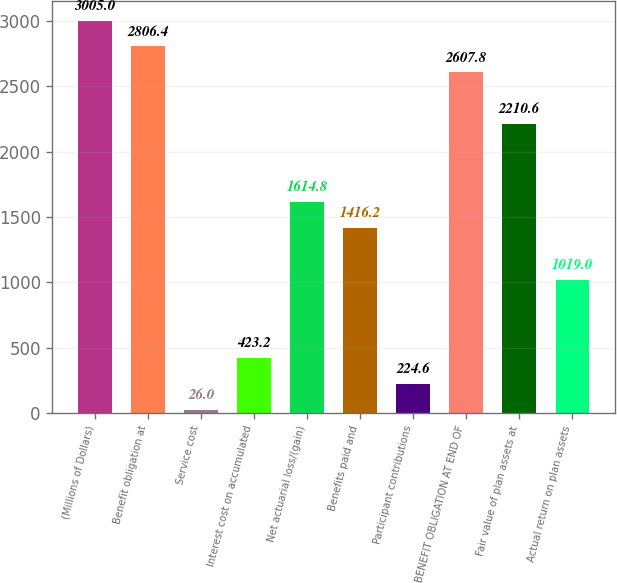Convert chart to OTSL. <chart><loc_0><loc_0><loc_500><loc_500><bar_chart><fcel>(Millions of Dollars)<fcel>Benefit obligation at<fcel>Service cost<fcel>Interest cost on accumulated<fcel>Net actuarial loss/(gain)<fcel>Benefits paid and<fcel>Participant contributions<fcel>BENEFIT OBLIGATION AT END OF<fcel>Fair value of plan assets at<fcel>Actual return on plan assets<nl><fcel>3005<fcel>2806.4<fcel>26<fcel>423.2<fcel>1614.8<fcel>1416.2<fcel>224.6<fcel>2607.8<fcel>2210.6<fcel>1019<nl></chart> 